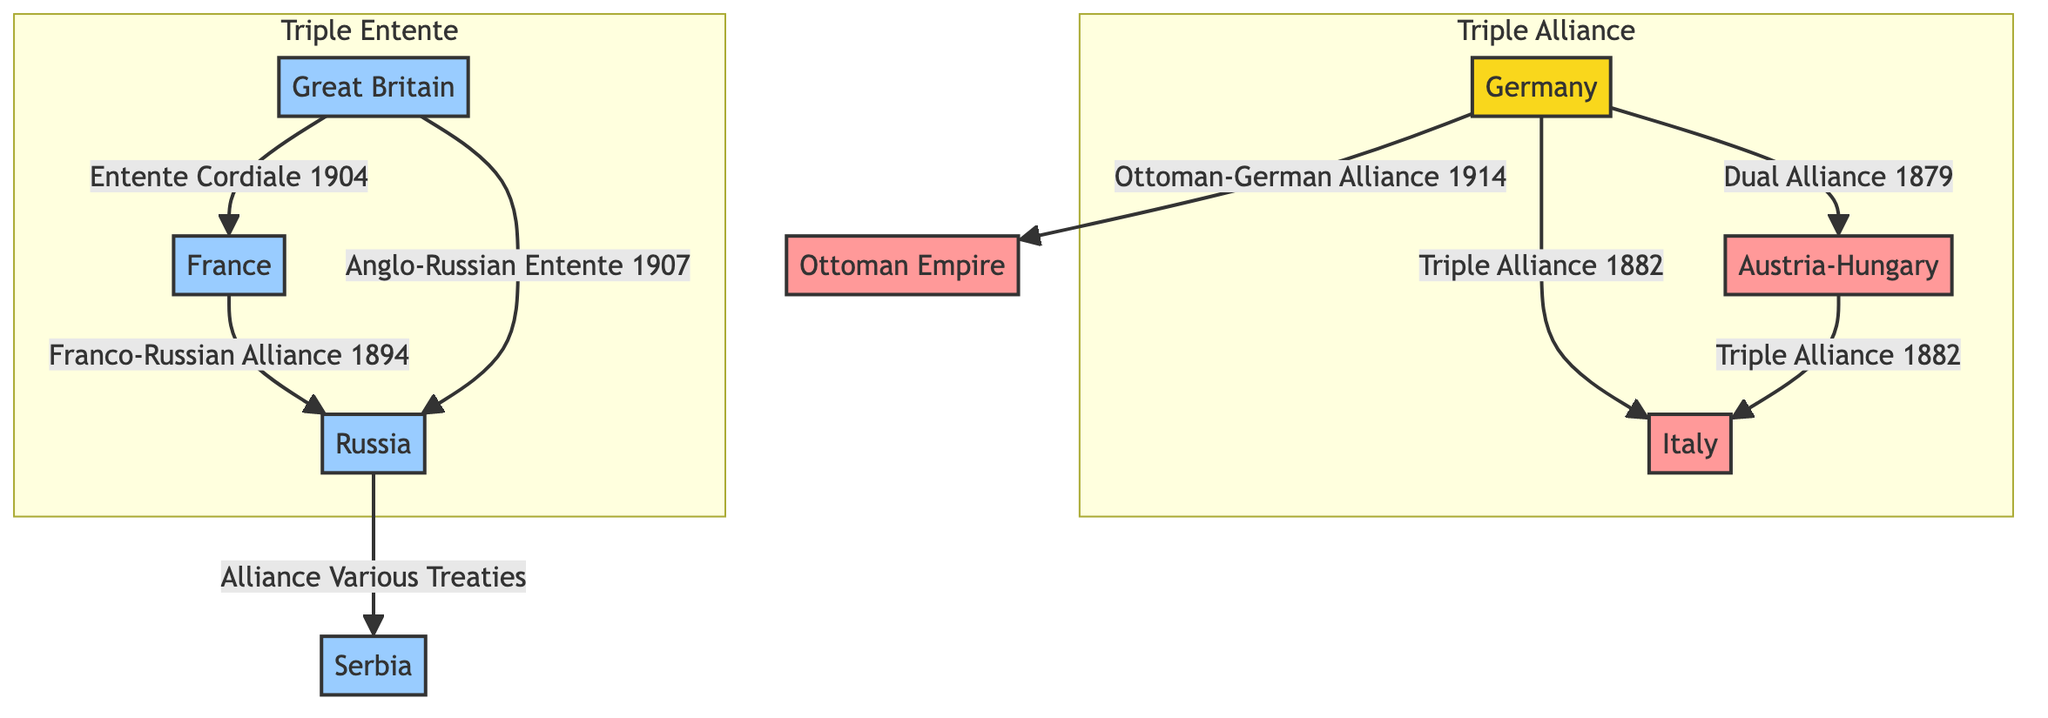What is the total number of major nations depicted in the diagram? The diagram includes the following major nations: Germany, Austria-Hungary, Italy, France, Russia, Great Britain, Serbia, and the Ottoman Empire. Counting these gives eight nations in total.
Answer: 8 Which two nations are connected by the Triple Alliance? The Triple Alliance is formed between Germany, Austria-Hungary, and Italy. In the diagram, it specifically indicates that Germany and Austria-Hungary are connected, and Italy is also part of the alliance.
Answer: Germany and Austria-Hungary What is the name of the alliance formed between France and Russia? The diagram states that France and Russia have a connection via the Franco-Russian Alliance established in 1894. This is clearly labeled in the diagram.
Answer: Franco-Russian Alliance Which nation has an alliance with Russia that includes Serbia? The diagram shows that Russia has an alliance with Serbia through various treaties. This relationship is explicitly indicated in the connections in the diagram.
Answer: Serbia How many edges are there connecting the ally nations in the Triple Alliance? In the diagram, the Triple Alliance has three edges: one from Germany to Austria-Hungary, one from Germany to Italy, and one from Austria-Hungary to Italy. Counting these connections provides a total of three edges within the Triple Alliance.
Answer: 3 Which nation forms an alliance with the Ottoman Empire, and what is that alliance called? The diagram indicates that Germany forms an alliance with the Ottoman Empire through the Ottoman-German Alliance established in 1914. This specific relationship is highlighted in the diagram.
Answer: Ottoman-German Alliance What is the relationship between Great Britain and France as shown in the diagram? The relationship between Great Britain and France is defined by the Entente Cordiale established in 1904, which is clearly labeled in the diagram between these two nations.
Answer: Entente Cordiale How many nations are part of the Triple Entente according to the diagram? The Triple Entente includes three nations: France, Russia, and Great Britain. The diagram clearly lists these nations as part of the subgraph labeled "Triple Entente."
Answer: 3 What is illustrated as the relationship between Germany and Italy? The diagram illustrates that Germany has a connection to Italy through the Triple Alliance established in 1882. This is clearly indicated within the network of alliances.
Answer: Triple Alliance 